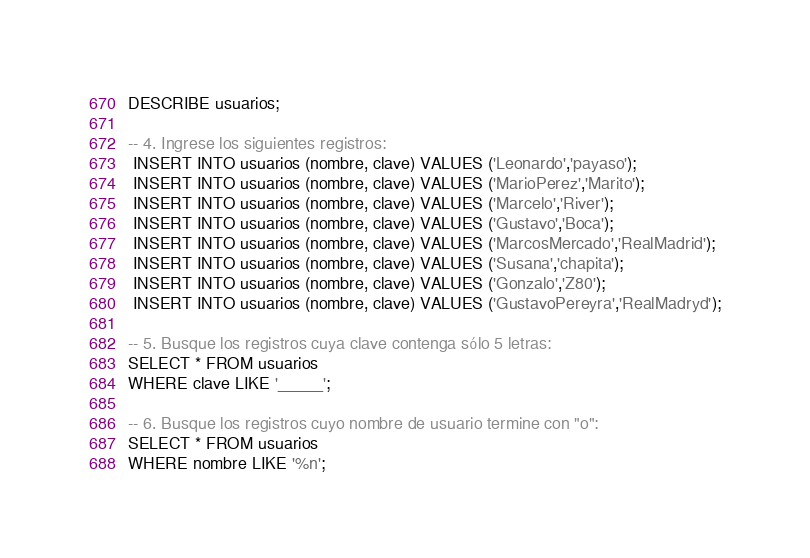Convert code to text. <code><loc_0><loc_0><loc_500><loc_500><_SQL_>DESCRIBE usuarios;

-- 4. Ingrese los siguientes registros:
 INSERT INTO usuarios (nombre, clave) VALUES ('Leonardo','payaso');
 INSERT INTO usuarios (nombre, clave) VALUES ('MarioPerez','Marito');
 INSERT INTO usuarios (nombre, clave) VALUES ('Marcelo','River');
 INSERT INTO usuarios (nombre, clave) VALUES ('Gustavo','Boca');
 INSERT INTO usuarios (nombre, clave) VALUES ('MarcosMercado','RealMadrid');
 INSERT INTO usuarios (nombre, clave) VALUES ('Susana','chapita');
 INSERT INTO usuarios (nombre, clave) VALUES ('Gonzalo','Z80');
 INSERT INTO usuarios (nombre, clave) VALUES ('GustavoPereyra','RealMadryd');

-- 5. Busque los registros cuya clave contenga sólo 5 letras:
SELECT * FROM usuarios
WHERE clave LIKE '_____';

-- 6. Busque los registros cuyo nombre de usuario termine con "o":
SELECT * FROM usuarios
WHERE nombre LIKE '%n';
</code> 